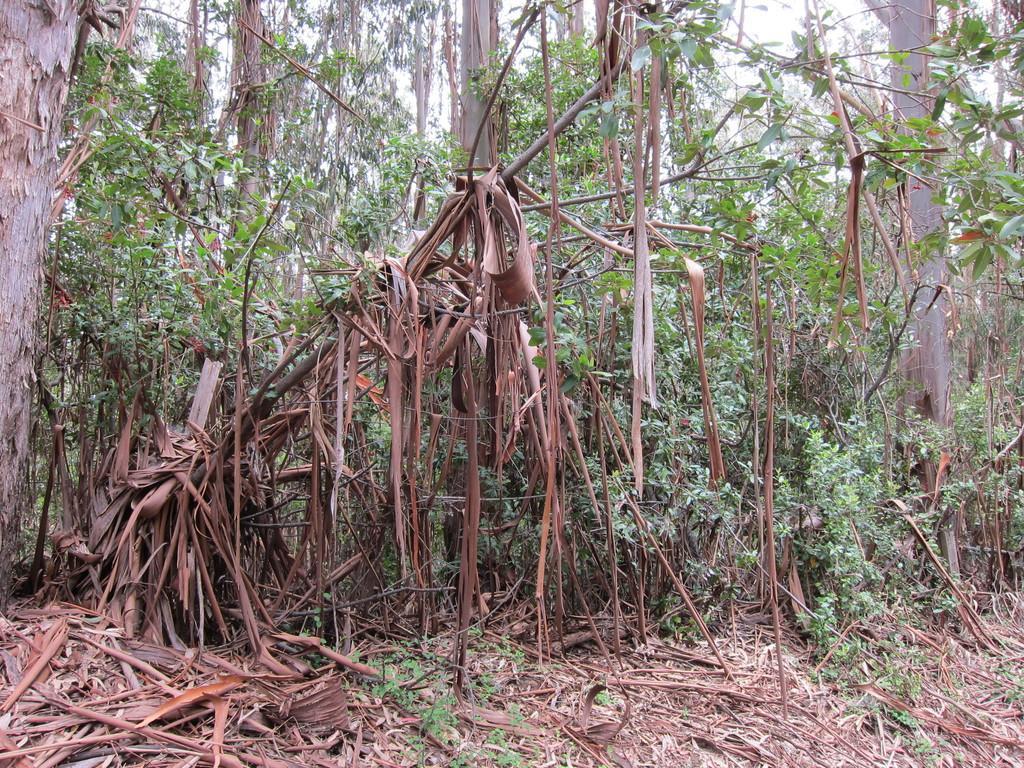Describe this image in one or two sentences. In the picture I can see dry plants and trees in the background. 